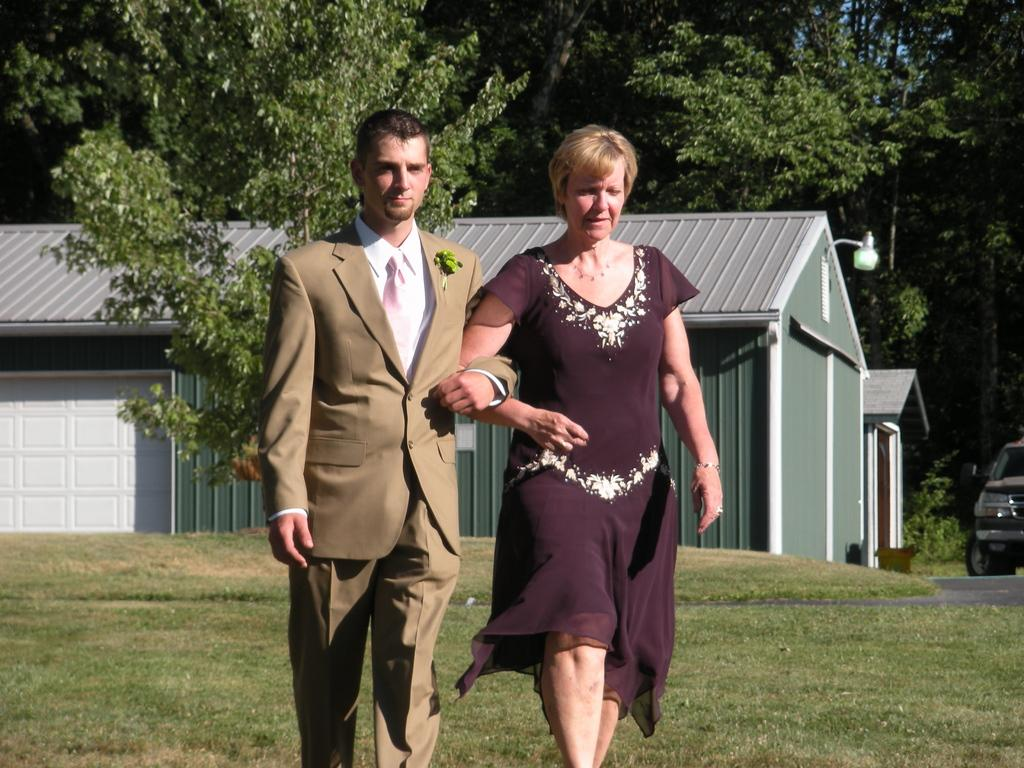How many humans are in the image? There are two humans in the image. What are the humans doing in the image? The humans are holding hands and walking. What can be seen in the background of the image? There are houses, at least one vehicle, grass, a road, and trees visible in the background of the image. What type of tax is being discussed by the humans in the image? There is no indication in the image that the humans are discussing any type of tax. Can you see a basket in the image? There is no basket present in the image. 